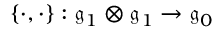Convert formula to latex. <formula><loc_0><loc_0><loc_500><loc_500>\{ \cdot , \cdot \} \colon { \mathfrak { g } } _ { 1 } \otimes { \mathfrak { g } } _ { 1 } \rightarrow { \mathfrak { g } } _ { 0 }</formula> 